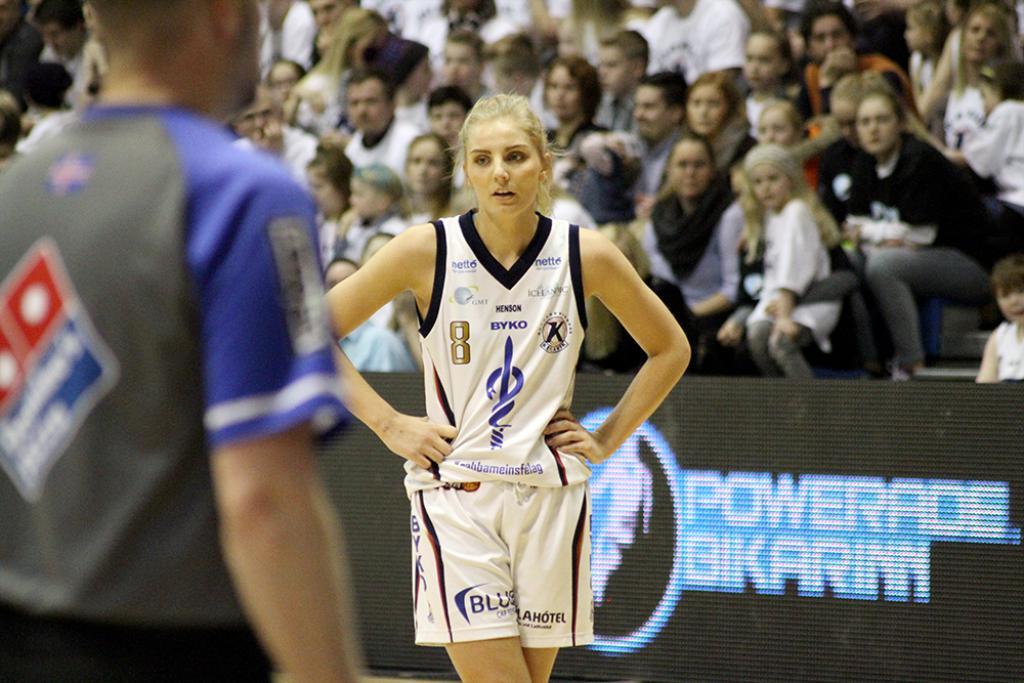What sponsor is on the grey shirt?
Make the answer very short. Domino's pizza. 